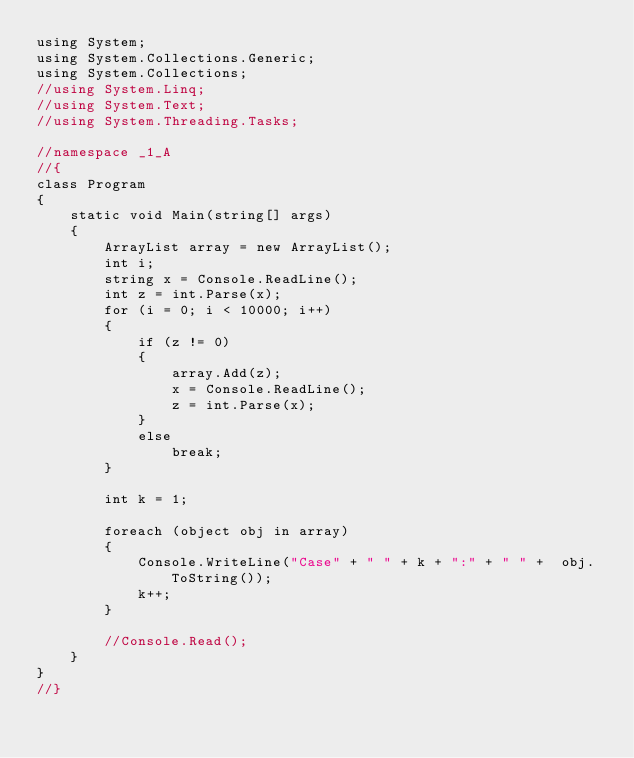<code> <loc_0><loc_0><loc_500><loc_500><_C#_>using System;
using System.Collections.Generic;
using System.Collections;
//using System.Linq;
//using System.Text;
//using System.Threading.Tasks;

//namespace _1_A
//{
class Program
{
    static void Main(string[] args)
    {
        ArrayList array = new ArrayList();
        int i;
        string x = Console.ReadLine();
        int z = int.Parse(x);
        for (i = 0; i < 10000; i++)
        {
            if (z != 0)
            {
                array.Add(z);
                x = Console.ReadLine();
                z = int.Parse(x);
            }
            else
                break;
        }

        int k = 1;

        foreach (object obj in array)
        {
            Console.WriteLine("Case" + " " + k + ":" + " " +  obj.ToString());
            k++;
        }

        //Console.Read();
    }
}
//}</code> 